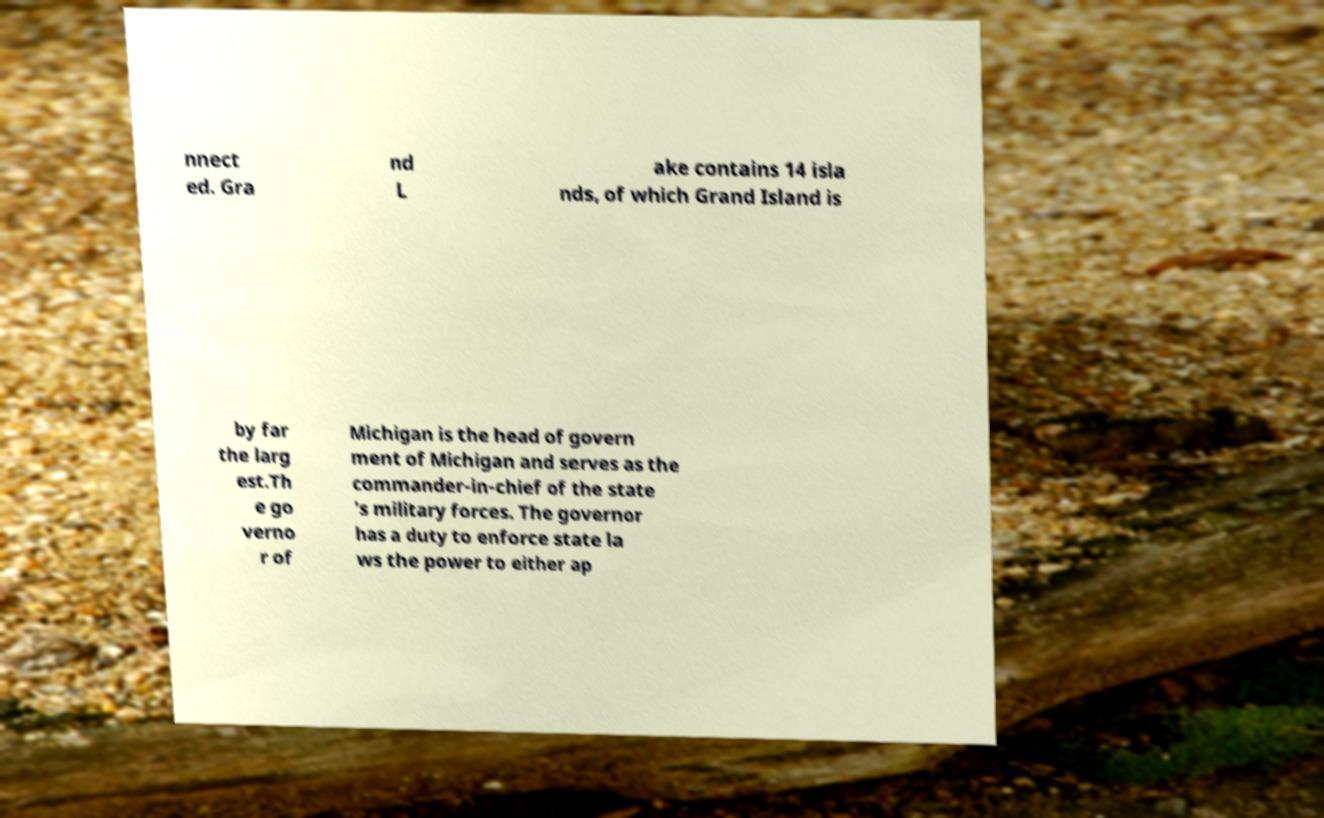Could you extract and type out the text from this image? nnect ed. Gra nd L ake contains 14 isla nds, of which Grand Island is by far the larg est.Th e go verno r of Michigan is the head of govern ment of Michigan and serves as the commander-in-chief of the state 's military forces. The governor has a duty to enforce state la ws the power to either ap 